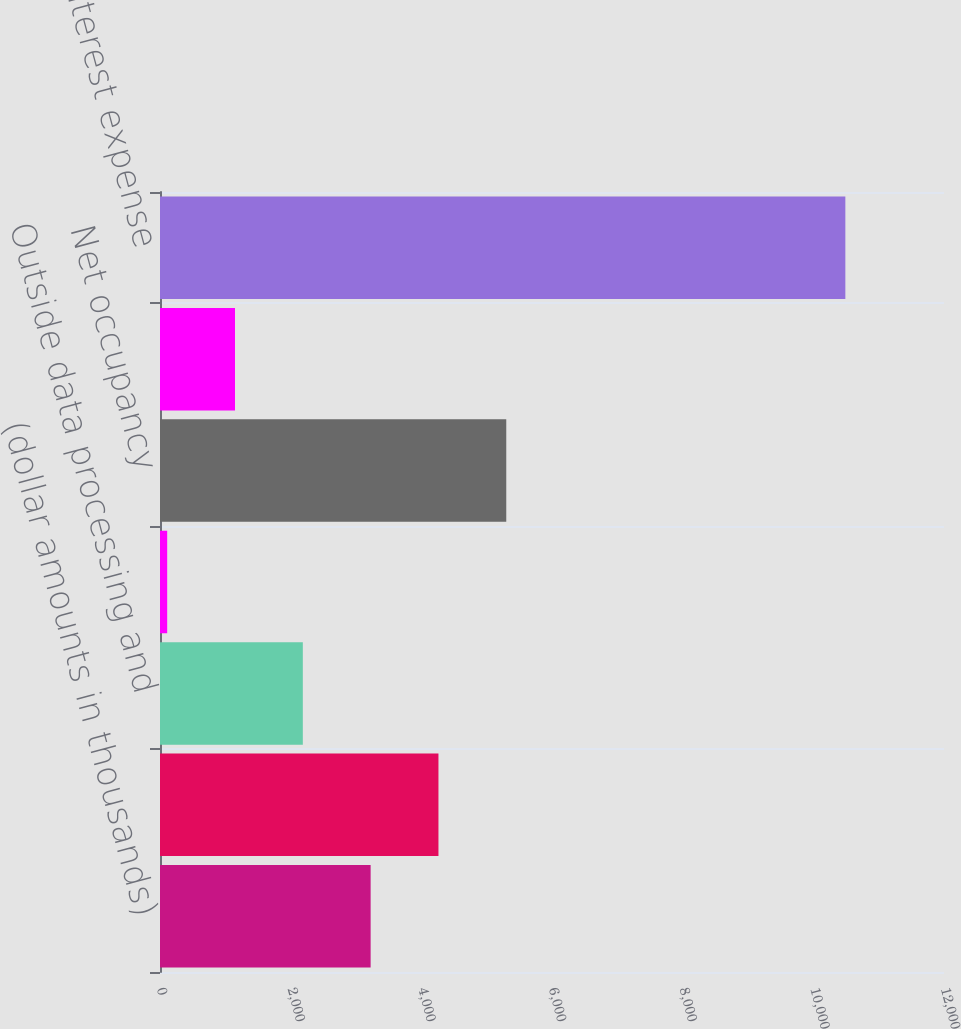Convert chart. <chart><loc_0><loc_0><loc_500><loc_500><bar_chart><fcel>(dollar amounts in thousands)<fcel>Personnel costs<fcel>Outside data processing and<fcel>Equipment<fcel>Net occupancy<fcel>Other expense<fcel>Total noninterest expense<nl><fcel>3224<fcel>4262<fcel>2186<fcel>110<fcel>5300<fcel>1148<fcel>10490<nl></chart> 